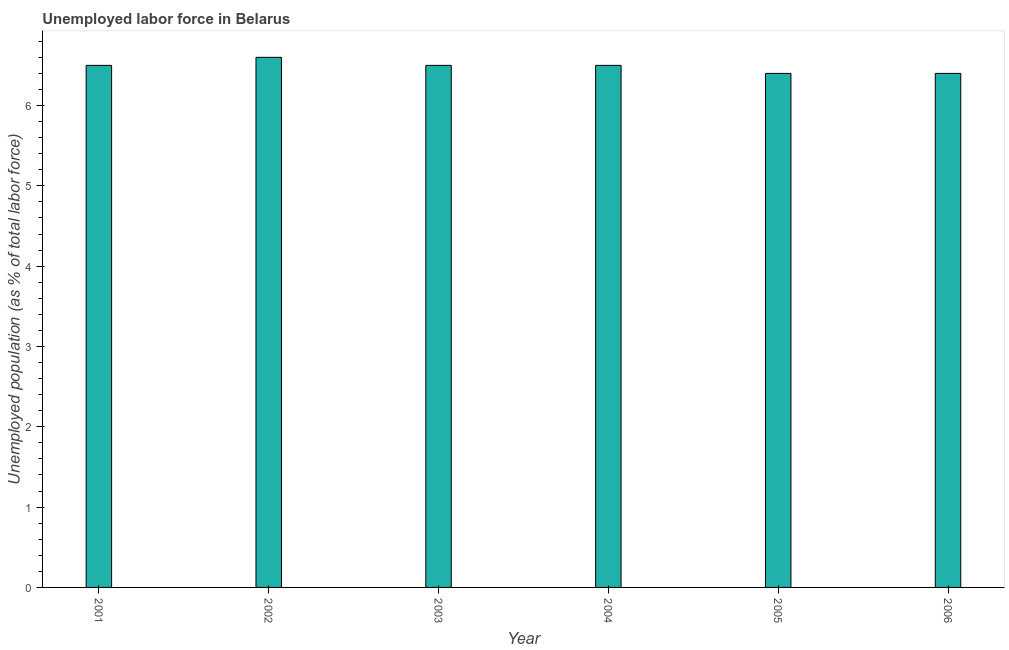Does the graph contain any zero values?
Provide a short and direct response. No. What is the title of the graph?
Ensure brevity in your answer.  Unemployed labor force in Belarus. What is the label or title of the Y-axis?
Offer a terse response. Unemployed population (as % of total labor force). What is the total unemployed population in 2002?
Give a very brief answer. 6.6. Across all years, what is the maximum total unemployed population?
Provide a succinct answer. 6.6. Across all years, what is the minimum total unemployed population?
Your answer should be very brief. 6.4. What is the sum of the total unemployed population?
Offer a very short reply. 38.9. What is the difference between the total unemployed population in 2005 and 2006?
Offer a terse response. 0. What is the average total unemployed population per year?
Make the answer very short. 6.48. What is the median total unemployed population?
Keep it short and to the point. 6.5. In how many years, is the total unemployed population greater than 0.8 %?
Provide a short and direct response. 6. Is the total unemployed population in 2001 less than that in 2004?
Make the answer very short. No. How many bars are there?
Provide a succinct answer. 6. How many years are there in the graph?
Provide a short and direct response. 6. What is the Unemployed population (as % of total labor force) of 2001?
Provide a short and direct response. 6.5. What is the Unemployed population (as % of total labor force) of 2002?
Your answer should be very brief. 6.6. What is the Unemployed population (as % of total labor force) in 2005?
Provide a succinct answer. 6.4. What is the Unemployed population (as % of total labor force) of 2006?
Give a very brief answer. 6.4. What is the difference between the Unemployed population (as % of total labor force) in 2001 and 2002?
Make the answer very short. -0.1. What is the difference between the Unemployed population (as % of total labor force) in 2001 and 2003?
Give a very brief answer. 0. What is the difference between the Unemployed population (as % of total labor force) in 2001 and 2005?
Make the answer very short. 0.1. What is the difference between the Unemployed population (as % of total labor force) in 2002 and 2003?
Keep it short and to the point. 0.1. What is the difference between the Unemployed population (as % of total labor force) in 2002 and 2004?
Your answer should be compact. 0.1. What is the difference between the Unemployed population (as % of total labor force) in 2002 and 2006?
Offer a very short reply. 0.2. What is the difference between the Unemployed population (as % of total labor force) in 2003 and 2004?
Offer a terse response. 0. What is the difference between the Unemployed population (as % of total labor force) in 2005 and 2006?
Ensure brevity in your answer.  0. What is the ratio of the Unemployed population (as % of total labor force) in 2001 to that in 2003?
Provide a succinct answer. 1. What is the ratio of the Unemployed population (as % of total labor force) in 2001 to that in 2004?
Offer a very short reply. 1. What is the ratio of the Unemployed population (as % of total labor force) in 2002 to that in 2003?
Offer a terse response. 1.01. What is the ratio of the Unemployed population (as % of total labor force) in 2002 to that in 2004?
Offer a very short reply. 1.01. What is the ratio of the Unemployed population (as % of total labor force) in 2002 to that in 2005?
Your response must be concise. 1.03. What is the ratio of the Unemployed population (as % of total labor force) in 2002 to that in 2006?
Keep it short and to the point. 1.03. What is the ratio of the Unemployed population (as % of total labor force) in 2003 to that in 2005?
Make the answer very short. 1.02. What is the ratio of the Unemployed population (as % of total labor force) in 2003 to that in 2006?
Ensure brevity in your answer.  1.02. 